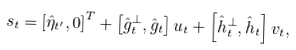Convert formula to latex. <formula><loc_0><loc_0><loc_500><loc_500>s _ { t } & = \left [ \hat { \eta } _ { t ^ { \prime } } , 0 \right ] ^ { T } + \left [ \hat { g } _ { t } ^ { \bot } , \hat { g } _ { t } \right ] u _ { t } + \left [ \hat { h } _ { t } ^ { \bot } , \hat { h } _ { t } \right ] v _ { t } ,</formula> 